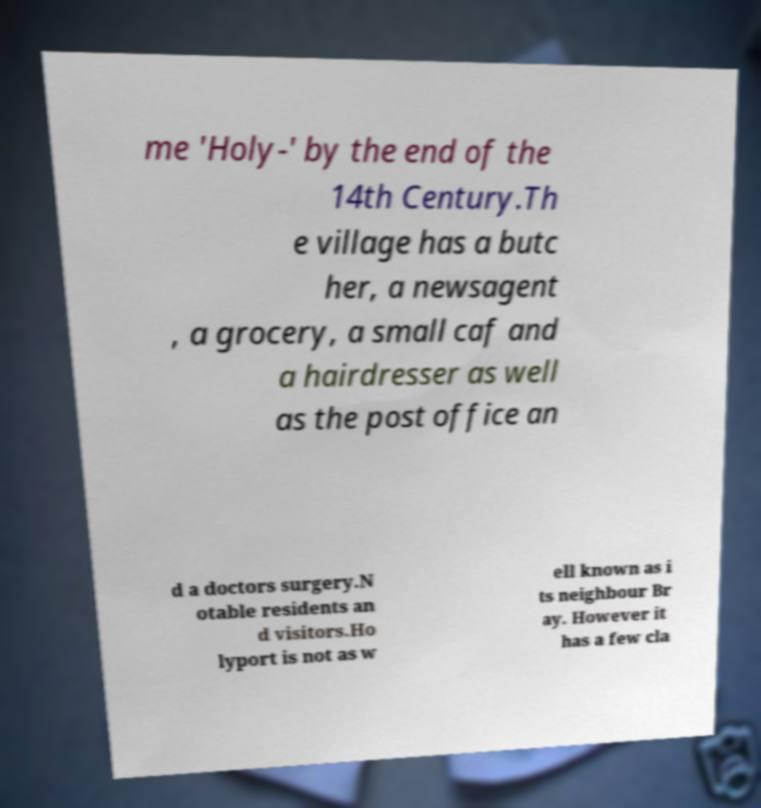Can you accurately transcribe the text from the provided image for me? me 'Holy-' by the end of the 14th Century.Th e village has a butc her, a newsagent , a grocery, a small caf and a hairdresser as well as the post office an d a doctors surgery.N otable residents an d visitors.Ho lyport is not as w ell known as i ts neighbour Br ay. However it has a few cla 